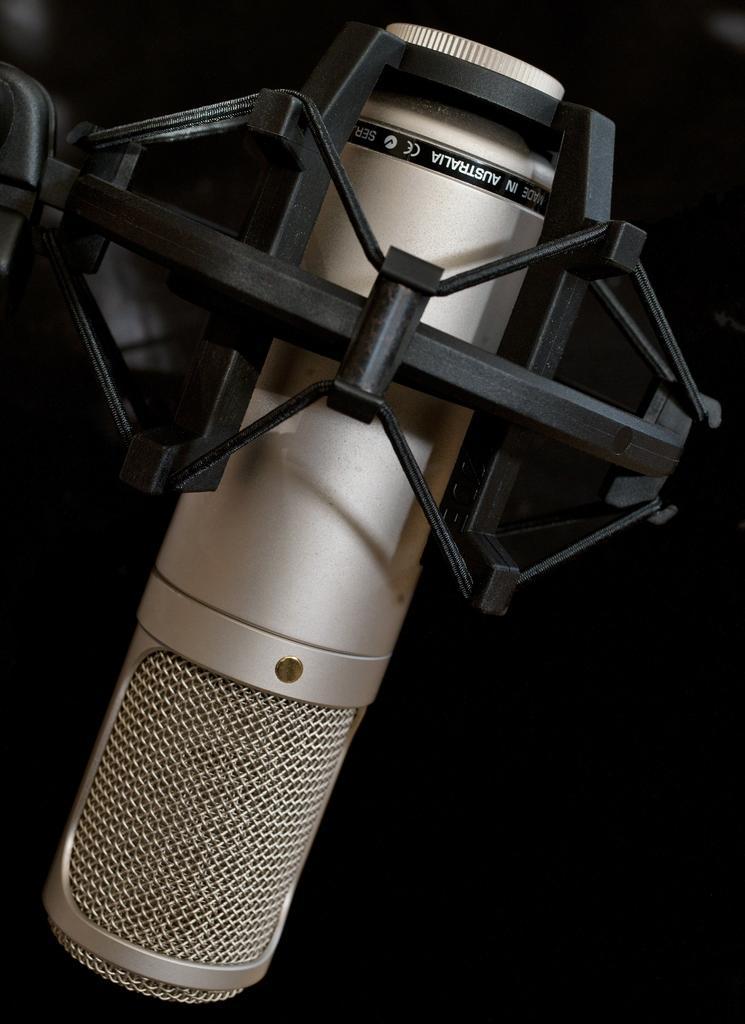Describe this image in one or two sentences. In this picture there is microphone on a microphone stand. There is text on it. The background is dark. 